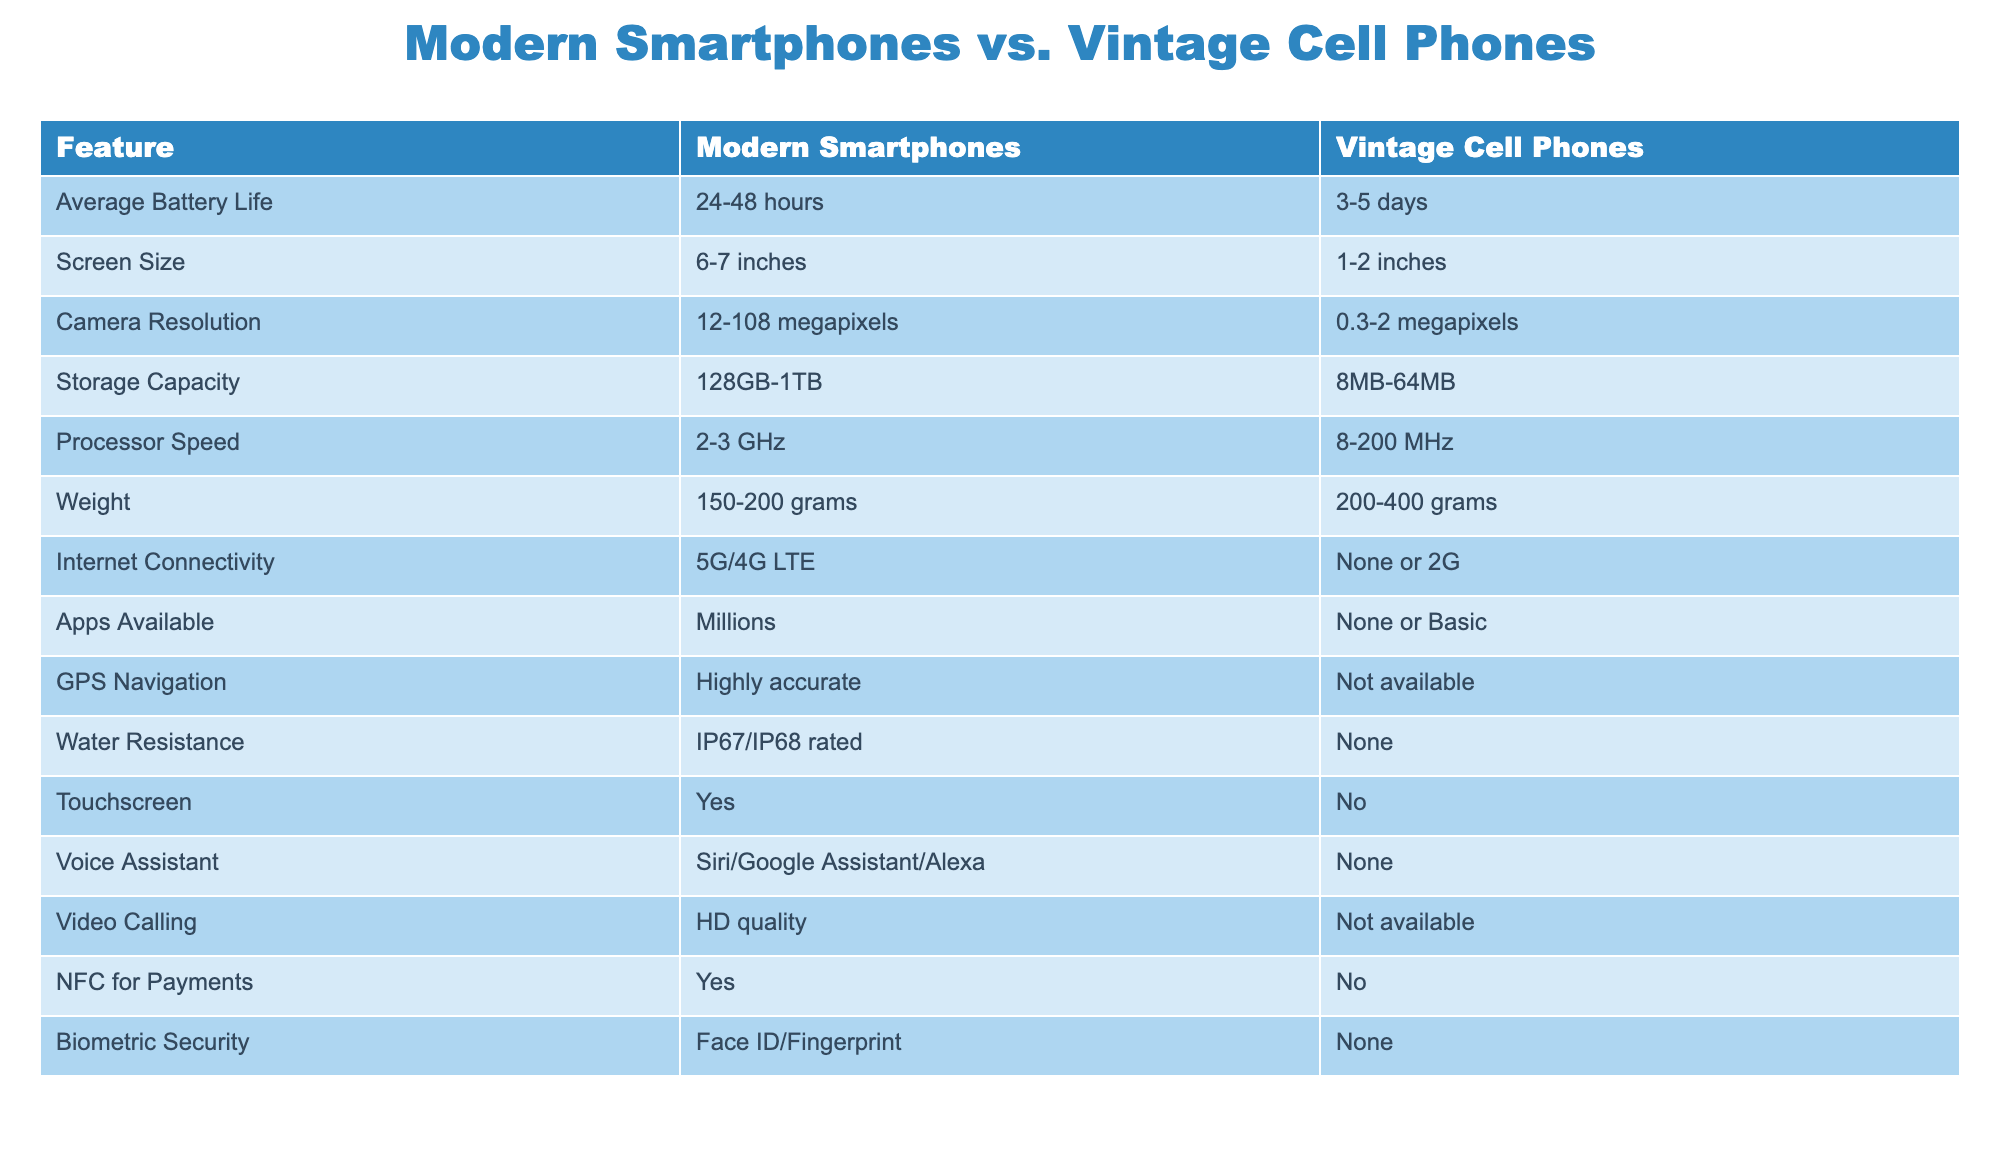What is the average battery life of modern smartphones? The table shows that modern smartphones have an average battery life of 24-48 hours. Since this is a range, the average can be estimated to be around (24 + 48) / 2 = 36 hours.
Answer: 36 hours Which has a larger screen size, modern smartphones or vintage cell phones? The table indicates that modern smartphones have a screen size of 6-7 inches, whereas vintage cell phones have a screen size of 1-2 inches. Therefore, modern smartphones have a larger screen size.
Answer: Modern smartphones What is the maximum camera resolution available for modern smartphones? By examining the table, it states that modern smartphones can have a camera resolution between 12-108 megapixels. The maximum value listed is 108 megapixels.
Answer: 108 megapixels Do vintage cell phones support GPS navigation? The table indicates that vintage cell phones do not have GPS navigation available at all. Therefore, the answer is no.
Answer: No What is the average storage capacity of vintage cell phones compared to modern smartphones? The table shows modern smartphones have a storage capacity ranging from 128GB to 1TB, while vintage cell phones range from 8MB to 64MB. If we calculate the average for modern smartphones as (128+1024)/2 = 576GB, and for vintage cell phones as (8+64)/2 = 36MB, modern smartphones have a significantly larger average capacity.
Answer: Modern smartphones have a larger average capacity What type of internet connectivity do vintage cell phones have? According to the table, vintage cell phones have either no internet connectivity or only 2G. This implies they lack modern connectivity options, making them far less capable than modern devices.
Answer: None or 2G Do modern smartphones include biometric security features? The table indicates that modern smartphones have biometric security features such as Face ID and fingerprint recognition, while vintage cell phones do not include this technology. Thus, yes, modern smartphones do possess this feature.
Answer: Yes How much more processing power do modern smartphones have compared to vintage cell phones? The table details that modern smartphones have a processor speed of 2-3 GHz while vintage cell phones vary from 8-200 MHz. To compare, we can look at the maximum; 3 GHz equals 3000 MHz. The difference is therefore 3000 - 200 = 2800 MHz, showcasing a substantial increase in processing power.
Answer: 2800 MHz 